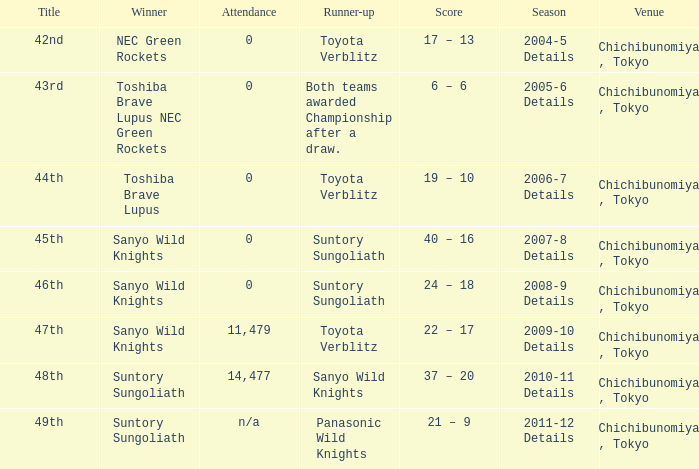What is the Score when the winner was suntory sungoliath, and the number attendance was n/a? 21 – 9. 